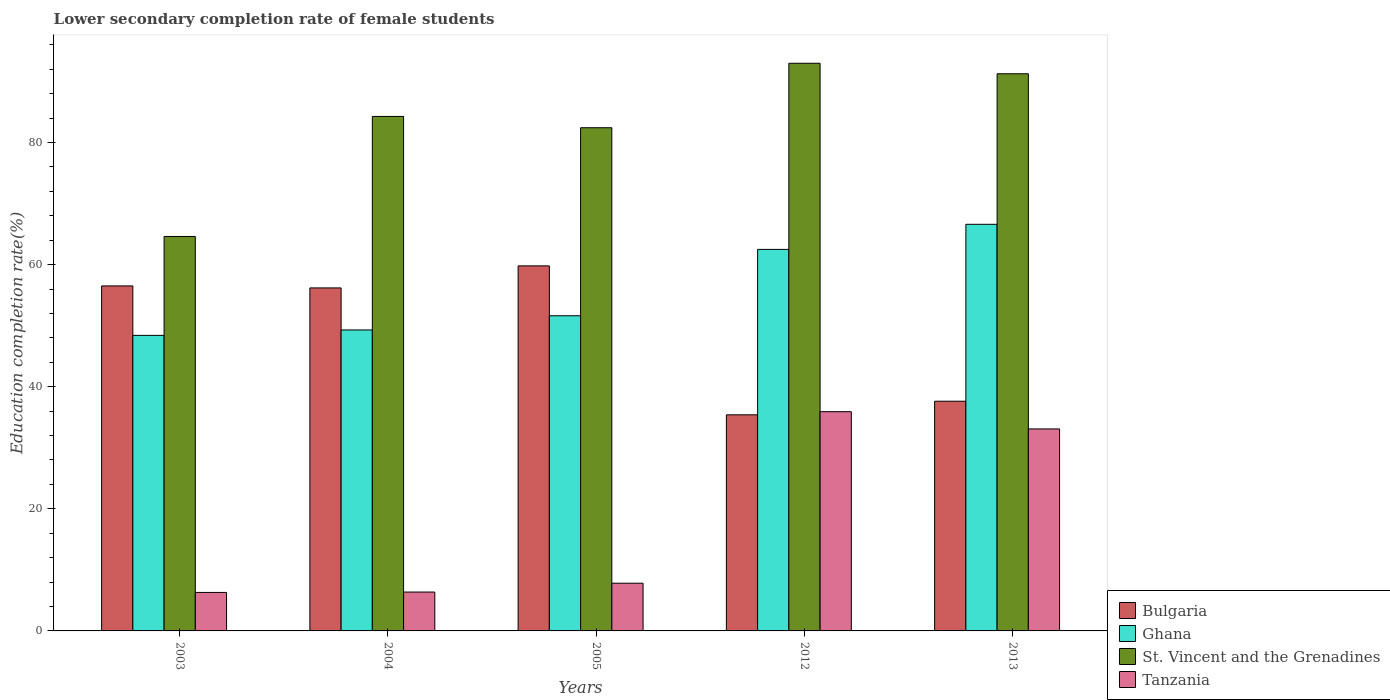How many different coloured bars are there?
Your answer should be very brief. 4. Are the number of bars on each tick of the X-axis equal?
Ensure brevity in your answer.  Yes. How many bars are there on the 4th tick from the right?
Offer a terse response. 4. What is the lower secondary completion rate of female students in Tanzania in 2005?
Ensure brevity in your answer.  7.81. Across all years, what is the maximum lower secondary completion rate of female students in Ghana?
Keep it short and to the point. 66.61. Across all years, what is the minimum lower secondary completion rate of female students in Ghana?
Your answer should be compact. 48.41. In which year was the lower secondary completion rate of female students in Ghana minimum?
Provide a succinct answer. 2003. What is the total lower secondary completion rate of female students in St. Vincent and the Grenadines in the graph?
Give a very brief answer. 415.58. What is the difference between the lower secondary completion rate of female students in Tanzania in 2004 and that in 2005?
Your answer should be compact. -1.45. What is the difference between the lower secondary completion rate of female students in Ghana in 2005 and the lower secondary completion rate of female students in Bulgaria in 2004?
Keep it short and to the point. -4.56. What is the average lower secondary completion rate of female students in Tanzania per year?
Provide a short and direct response. 17.9. In the year 2003, what is the difference between the lower secondary completion rate of female students in St. Vincent and the Grenadines and lower secondary completion rate of female students in Bulgaria?
Keep it short and to the point. 8.1. In how many years, is the lower secondary completion rate of female students in St. Vincent and the Grenadines greater than 64 %?
Offer a very short reply. 5. What is the ratio of the lower secondary completion rate of female students in Bulgaria in 2004 to that in 2012?
Provide a short and direct response. 1.59. What is the difference between the highest and the second highest lower secondary completion rate of female students in Ghana?
Your response must be concise. 4.11. What is the difference between the highest and the lowest lower secondary completion rate of female students in St. Vincent and the Grenadines?
Ensure brevity in your answer.  28.37. Is it the case that in every year, the sum of the lower secondary completion rate of female students in Ghana and lower secondary completion rate of female students in Bulgaria is greater than the sum of lower secondary completion rate of female students in St. Vincent and the Grenadines and lower secondary completion rate of female students in Tanzania?
Offer a terse response. No. What does the 3rd bar from the left in 2012 represents?
Make the answer very short. St. Vincent and the Grenadines. What does the 3rd bar from the right in 2012 represents?
Give a very brief answer. Ghana. Is it the case that in every year, the sum of the lower secondary completion rate of female students in Tanzania and lower secondary completion rate of female students in St. Vincent and the Grenadines is greater than the lower secondary completion rate of female students in Ghana?
Provide a short and direct response. Yes. How many bars are there?
Your response must be concise. 20. Are all the bars in the graph horizontal?
Ensure brevity in your answer.  No. Are the values on the major ticks of Y-axis written in scientific E-notation?
Provide a short and direct response. No. Does the graph contain any zero values?
Ensure brevity in your answer.  No. Where does the legend appear in the graph?
Make the answer very short. Bottom right. How are the legend labels stacked?
Make the answer very short. Vertical. What is the title of the graph?
Offer a terse response. Lower secondary completion rate of female students. What is the label or title of the X-axis?
Your answer should be compact. Years. What is the label or title of the Y-axis?
Make the answer very short. Education completion rate(%). What is the Education completion rate(%) in Bulgaria in 2003?
Your answer should be compact. 56.52. What is the Education completion rate(%) of Ghana in 2003?
Give a very brief answer. 48.41. What is the Education completion rate(%) of St. Vincent and the Grenadines in 2003?
Make the answer very short. 64.62. What is the Education completion rate(%) of Tanzania in 2003?
Offer a very short reply. 6.31. What is the Education completion rate(%) of Bulgaria in 2004?
Your response must be concise. 56.19. What is the Education completion rate(%) of Ghana in 2004?
Keep it short and to the point. 49.3. What is the Education completion rate(%) of St. Vincent and the Grenadines in 2004?
Provide a short and direct response. 84.28. What is the Education completion rate(%) of Tanzania in 2004?
Provide a succinct answer. 6.37. What is the Education completion rate(%) of Bulgaria in 2005?
Offer a terse response. 59.8. What is the Education completion rate(%) of Ghana in 2005?
Give a very brief answer. 51.63. What is the Education completion rate(%) of St. Vincent and the Grenadines in 2005?
Your answer should be very brief. 82.43. What is the Education completion rate(%) in Tanzania in 2005?
Make the answer very short. 7.81. What is the Education completion rate(%) of Bulgaria in 2012?
Ensure brevity in your answer.  35.4. What is the Education completion rate(%) of Ghana in 2012?
Make the answer very short. 62.5. What is the Education completion rate(%) in St. Vincent and the Grenadines in 2012?
Offer a terse response. 92.99. What is the Education completion rate(%) of Tanzania in 2012?
Keep it short and to the point. 35.92. What is the Education completion rate(%) of Bulgaria in 2013?
Offer a very short reply. 37.63. What is the Education completion rate(%) in Ghana in 2013?
Your response must be concise. 66.61. What is the Education completion rate(%) in St. Vincent and the Grenadines in 2013?
Give a very brief answer. 91.27. What is the Education completion rate(%) of Tanzania in 2013?
Ensure brevity in your answer.  33.09. Across all years, what is the maximum Education completion rate(%) in Bulgaria?
Offer a very short reply. 59.8. Across all years, what is the maximum Education completion rate(%) of Ghana?
Your answer should be compact. 66.61. Across all years, what is the maximum Education completion rate(%) of St. Vincent and the Grenadines?
Make the answer very short. 92.99. Across all years, what is the maximum Education completion rate(%) of Tanzania?
Your response must be concise. 35.92. Across all years, what is the minimum Education completion rate(%) in Bulgaria?
Ensure brevity in your answer.  35.4. Across all years, what is the minimum Education completion rate(%) of Ghana?
Your answer should be compact. 48.41. Across all years, what is the minimum Education completion rate(%) of St. Vincent and the Grenadines?
Ensure brevity in your answer.  64.62. Across all years, what is the minimum Education completion rate(%) in Tanzania?
Your answer should be compact. 6.31. What is the total Education completion rate(%) of Bulgaria in the graph?
Ensure brevity in your answer.  245.53. What is the total Education completion rate(%) in Ghana in the graph?
Your answer should be very brief. 278.45. What is the total Education completion rate(%) in St. Vincent and the Grenadines in the graph?
Your answer should be very brief. 415.58. What is the total Education completion rate(%) of Tanzania in the graph?
Give a very brief answer. 89.49. What is the difference between the Education completion rate(%) in Bulgaria in 2003 and that in 2004?
Your answer should be compact. 0.33. What is the difference between the Education completion rate(%) of Ghana in 2003 and that in 2004?
Offer a very short reply. -0.89. What is the difference between the Education completion rate(%) in St. Vincent and the Grenadines in 2003 and that in 2004?
Your answer should be compact. -19.66. What is the difference between the Education completion rate(%) in Tanzania in 2003 and that in 2004?
Ensure brevity in your answer.  -0.06. What is the difference between the Education completion rate(%) of Bulgaria in 2003 and that in 2005?
Give a very brief answer. -3.28. What is the difference between the Education completion rate(%) in Ghana in 2003 and that in 2005?
Offer a terse response. -3.21. What is the difference between the Education completion rate(%) of St. Vincent and the Grenadines in 2003 and that in 2005?
Ensure brevity in your answer.  -17.81. What is the difference between the Education completion rate(%) in Tanzania in 2003 and that in 2005?
Provide a short and direct response. -1.51. What is the difference between the Education completion rate(%) of Bulgaria in 2003 and that in 2012?
Keep it short and to the point. 21.12. What is the difference between the Education completion rate(%) in Ghana in 2003 and that in 2012?
Your answer should be compact. -14.08. What is the difference between the Education completion rate(%) of St. Vincent and the Grenadines in 2003 and that in 2012?
Provide a short and direct response. -28.37. What is the difference between the Education completion rate(%) in Tanzania in 2003 and that in 2012?
Ensure brevity in your answer.  -29.61. What is the difference between the Education completion rate(%) in Bulgaria in 2003 and that in 2013?
Offer a terse response. 18.89. What is the difference between the Education completion rate(%) of Ghana in 2003 and that in 2013?
Your response must be concise. -18.19. What is the difference between the Education completion rate(%) of St. Vincent and the Grenadines in 2003 and that in 2013?
Your answer should be compact. -26.65. What is the difference between the Education completion rate(%) in Tanzania in 2003 and that in 2013?
Offer a terse response. -26.78. What is the difference between the Education completion rate(%) of Bulgaria in 2004 and that in 2005?
Ensure brevity in your answer.  -3.61. What is the difference between the Education completion rate(%) in Ghana in 2004 and that in 2005?
Provide a short and direct response. -2.33. What is the difference between the Education completion rate(%) in St. Vincent and the Grenadines in 2004 and that in 2005?
Give a very brief answer. 1.85. What is the difference between the Education completion rate(%) of Tanzania in 2004 and that in 2005?
Your answer should be very brief. -1.45. What is the difference between the Education completion rate(%) of Bulgaria in 2004 and that in 2012?
Ensure brevity in your answer.  20.79. What is the difference between the Education completion rate(%) in Ghana in 2004 and that in 2012?
Offer a terse response. -13.2. What is the difference between the Education completion rate(%) in St. Vincent and the Grenadines in 2004 and that in 2012?
Keep it short and to the point. -8.71. What is the difference between the Education completion rate(%) of Tanzania in 2004 and that in 2012?
Offer a very short reply. -29.55. What is the difference between the Education completion rate(%) in Bulgaria in 2004 and that in 2013?
Your answer should be compact. 18.56. What is the difference between the Education completion rate(%) of Ghana in 2004 and that in 2013?
Keep it short and to the point. -17.31. What is the difference between the Education completion rate(%) of St. Vincent and the Grenadines in 2004 and that in 2013?
Make the answer very short. -6.99. What is the difference between the Education completion rate(%) of Tanzania in 2004 and that in 2013?
Offer a terse response. -26.72. What is the difference between the Education completion rate(%) in Bulgaria in 2005 and that in 2012?
Offer a terse response. 24.4. What is the difference between the Education completion rate(%) of Ghana in 2005 and that in 2012?
Offer a terse response. -10.87. What is the difference between the Education completion rate(%) in St. Vincent and the Grenadines in 2005 and that in 2012?
Keep it short and to the point. -10.56. What is the difference between the Education completion rate(%) of Tanzania in 2005 and that in 2012?
Give a very brief answer. -28.1. What is the difference between the Education completion rate(%) in Bulgaria in 2005 and that in 2013?
Provide a short and direct response. 22.17. What is the difference between the Education completion rate(%) in Ghana in 2005 and that in 2013?
Give a very brief answer. -14.98. What is the difference between the Education completion rate(%) of St. Vincent and the Grenadines in 2005 and that in 2013?
Keep it short and to the point. -8.84. What is the difference between the Education completion rate(%) in Tanzania in 2005 and that in 2013?
Your answer should be compact. -25.27. What is the difference between the Education completion rate(%) of Bulgaria in 2012 and that in 2013?
Your response must be concise. -2.23. What is the difference between the Education completion rate(%) of Ghana in 2012 and that in 2013?
Offer a terse response. -4.11. What is the difference between the Education completion rate(%) in St. Vincent and the Grenadines in 2012 and that in 2013?
Keep it short and to the point. 1.72. What is the difference between the Education completion rate(%) of Tanzania in 2012 and that in 2013?
Your answer should be very brief. 2.83. What is the difference between the Education completion rate(%) in Bulgaria in 2003 and the Education completion rate(%) in Ghana in 2004?
Provide a succinct answer. 7.22. What is the difference between the Education completion rate(%) in Bulgaria in 2003 and the Education completion rate(%) in St. Vincent and the Grenadines in 2004?
Keep it short and to the point. -27.76. What is the difference between the Education completion rate(%) in Bulgaria in 2003 and the Education completion rate(%) in Tanzania in 2004?
Offer a very short reply. 50.15. What is the difference between the Education completion rate(%) of Ghana in 2003 and the Education completion rate(%) of St. Vincent and the Grenadines in 2004?
Provide a succinct answer. -35.86. What is the difference between the Education completion rate(%) of Ghana in 2003 and the Education completion rate(%) of Tanzania in 2004?
Give a very brief answer. 42.05. What is the difference between the Education completion rate(%) in St. Vincent and the Grenadines in 2003 and the Education completion rate(%) in Tanzania in 2004?
Give a very brief answer. 58.25. What is the difference between the Education completion rate(%) of Bulgaria in 2003 and the Education completion rate(%) of Ghana in 2005?
Give a very brief answer. 4.89. What is the difference between the Education completion rate(%) of Bulgaria in 2003 and the Education completion rate(%) of St. Vincent and the Grenadines in 2005?
Your answer should be very brief. -25.91. What is the difference between the Education completion rate(%) of Bulgaria in 2003 and the Education completion rate(%) of Tanzania in 2005?
Give a very brief answer. 48.7. What is the difference between the Education completion rate(%) of Ghana in 2003 and the Education completion rate(%) of St. Vincent and the Grenadines in 2005?
Offer a terse response. -34.01. What is the difference between the Education completion rate(%) in Ghana in 2003 and the Education completion rate(%) in Tanzania in 2005?
Your answer should be compact. 40.6. What is the difference between the Education completion rate(%) in St. Vincent and the Grenadines in 2003 and the Education completion rate(%) in Tanzania in 2005?
Your answer should be compact. 56.8. What is the difference between the Education completion rate(%) in Bulgaria in 2003 and the Education completion rate(%) in Ghana in 2012?
Your response must be concise. -5.98. What is the difference between the Education completion rate(%) of Bulgaria in 2003 and the Education completion rate(%) of St. Vincent and the Grenadines in 2012?
Your response must be concise. -36.47. What is the difference between the Education completion rate(%) of Bulgaria in 2003 and the Education completion rate(%) of Tanzania in 2012?
Keep it short and to the point. 20.6. What is the difference between the Education completion rate(%) in Ghana in 2003 and the Education completion rate(%) in St. Vincent and the Grenadines in 2012?
Your answer should be very brief. -44.57. What is the difference between the Education completion rate(%) in Ghana in 2003 and the Education completion rate(%) in Tanzania in 2012?
Make the answer very short. 12.5. What is the difference between the Education completion rate(%) in St. Vincent and the Grenadines in 2003 and the Education completion rate(%) in Tanzania in 2012?
Your answer should be very brief. 28.7. What is the difference between the Education completion rate(%) of Bulgaria in 2003 and the Education completion rate(%) of Ghana in 2013?
Ensure brevity in your answer.  -10.09. What is the difference between the Education completion rate(%) of Bulgaria in 2003 and the Education completion rate(%) of St. Vincent and the Grenadines in 2013?
Make the answer very short. -34.75. What is the difference between the Education completion rate(%) of Bulgaria in 2003 and the Education completion rate(%) of Tanzania in 2013?
Your response must be concise. 23.43. What is the difference between the Education completion rate(%) in Ghana in 2003 and the Education completion rate(%) in St. Vincent and the Grenadines in 2013?
Your answer should be very brief. -42.86. What is the difference between the Education completion rate(%) of Ghana in 2003 and the Education completion rate(%) of Tanzania in 2013?
Your response must be concise. 15.32. What is the difference between the Education completion rate(%) in St. Vincent and the Grenadines in 2003 and the Education completion rate(%) in Tanzania in 2013?
Give a very brief answer. 31.53. What is the difference between the Education completion rate(%) of Bulgaria in 2004 and the Education completion rate(%) of Ghana in 2005?
Your response must be concise. 4.56. What is the difference between the Education completion rate(%) in Bulgaria in 2004 and the Education completion rate(%) in St. Vincent and the Grenadines in 2005?
Your answer should be very brief. -26.24. What is the difference between the Education completion rate(%) in Bulgaria in 2004 and the Education completion rate(%) in Tanzania in 2005?
Provide a succinct answer. 48.37. What is the difference between the Education completion rate(%) in Ghana in 2004 and the Education completion rate(%) in St. Vincent and the Grenadines in 2005?
Provide a short and direct response. -33.13. What is the difference between the Education completion rate(%) of Ghana in 2004 and the Education completion rate(%) of Tanzania in 2005?
Offer a very short reply. 41.48. What is the difference between the Education completion rate(%) in St. Vincent and the Grenadines in 2004 and the Education completion rate(%) in Tanzania in 2005?
Offer a terse response. 76.46. What is the difference between the Education completion rate(%) in Bulgaria in 2004 and the Education completion rate(%) in Ghana in 2012?
Offer a terse response. -6.31. What is the difference between the Education completion rate(%) in Bulgaria in 2004 and the Education completion rate(%) in St. Vincent and the Grenadines in 2012?
Your answer should be compact. -36.8. What is the difference between the Education completion rate(%) of Bulgaria in 2004 and the Education completion rate(%) of Tanzania in 2012?
Provide a short and direct response. 20.27. What is the difference between the Education completion rate(%) of Ghana in 2004 and the Education completion rate(%) of St. Vincent and the Grenadines in 2012?
Offer a very short reply. -43.69. What is the difference between the Education completion rate(%) in Ghana in 2004 and the Education completion rate(%) in Tanzania in 2012?
Give a very brief answer. 13.38. What is the difference between the Education completion rate(%) in St. Vincent and the Grenadines in 2004 and the Education completion rate(%) in Tanzania in 2012?
Offer a terse response. 48.36. What is the difference between the Education completion rate(%) of Bulgaria in 2004 and the Education completion rate(%) of Ghana in 2013?
Provide a succinct answer. -10.42. What is the difference between the Education completion rate(%) of Bulgaria in 2004 and the Education completion rate(%) of St. Vincent and the Grenadines in 2013?
Your response must be concise. -35.08. What is the difference between the Education completion rate(%) of Bulgaria in 2004 and the Education completion rate(%) of Tanzania in 2013?
Offer a terse response. 23.1. What is the difference between the Education completion rate(%) in Ghana in 2004 and the Education completion rate(%) in St. Vincent and the Grenadines in 2013?
Give a very brief answer. -41.97. What is the difference between the Education completion rate(%) of Ghana in 2004 and the Education completion rate(%) of Tanzania in 2013?
Provide a succinct answer. 16.21. What is the difference between the Education completion rate(%) in St. Vincent and the Grenadines in 2004 and the Education completion rate(%) in Tanzania in 2013?
Provide a short and direct response. 51.19. What is the difference between the Education completion rate(%) of Bulgaria in 2005 and the Education completion rate(%) of Ghana in 2012?
Keep it short and to the point. -2.7. What is the difference between the Education completion rate(%) of Bulgaria in 2005 and the Education completion rate(%) of St. Vincent and the Grenadines in 2012?
Offer a terse response. -33.19. What is the difference between the Education completion rate(%) of Bulgaria in 2005 and the Education completion rate(%) of Tanzania in 2012?
Offer a very short reply. 23.88. What is the difference between the Education completion rate(%) in Ghana in 2005 and the Education completion rate(%) in St. Vincent and the Grenadines in 2012?
Give a very brief answer. -41.36. What is the difference between the Education completion rate(%) in Ghana in 2005 and the Education completion rate(%) in Tanzania in 2012?
Ensure brevity in your answer.  15.71. What is the difference between the Education completion rate(%) in St. Vincent and the Grenadines in 2005 and the Education completion rate(%) in Tanzania in 2012?
Your answer should be very brief. 46.51. What is the difference between the Education completion rate(%) of Bulgaria in 2005 and the Education completion rate(%) of Ghana in 2013?
Your answer should be compact. -6.81. What is the difference between the Education completion rate(%) in Bulgaria in 2005 and the Education completion rate(%) in St. Vincent and the Grenadines in 2013?
Keep it short and to the point. -31.47. What is the difference between the Education completion rate(%) in Bulgaria in 2005 and the Education completion rate(%) in Tanzania in 2013?
Your response must be concise. 26.71. What is the difference between the Education completion rate(%) of Ghana in 2005 and the Education completion rate(%) of St. Vincent and the Grenadines in 2013?
Your answer should be very brief. -39.64. What is the difference between the Education completion rate(%) of Ghana in 2005 and the Education completion rate(%) of Tanzania in 2013?
Offer a terse response. 18.54. What is the difference between the Education completion rate(%) of St. Vincent and the Grenadines in 2005 and the Education completion rate(%) of Tanzania in 2013?
Ensure brevity in your answer.  49.34. What is the difference between the Education completion rate(%) in Bulgaria in 2012 and the Education completion rate(%) in Ghana in 2013?
Offer a very short reply. -31.21. What is the difference between the Education completion rate(%) in Bulgaria in 2012 and the Education completion rate(%) in St. Vincent and the Grenadines in 2013?
Keep it short and to the point. -55.87. What is the difference between the Education completion rate(%) of Bulgaria in 2012 and the Education completion rate(%) of Tanzania in 2013?
Your answer should be very brief. 2.31. What is the difference between the Education completion rate(%) in Ghana in 2012 and the Education completion rate(%) in St. Vincent and the Grenadines in 2013?
Keep it short and to the point. -28.77. What is the difference between the Education completion rate(%) of Ghana in 2012 and the Education completion rate(%) of Tanzania in 2013?
Your answer should be very brief. 29.41. What is the difference between the Education completion rate(%) of St. Vincent and the Grenadines in 2012 and the Education completion rate(%) of Tanzania in 2013?
Give a very brief answer. 59.9. What is the average Education completion rate(%) of Bulgaria per year?
Make the answer very short. 49.11. What is the average Education completion rate(%) of Ghana per year?
Offer a terse response. 55.69. What is the average Education completion rate(%) of St. Vincent and the Grenadines per year?
Offer a very short reply. 83.12. What is the average Education completion rate(%) in Tanzania per year?
Your answer should be very brief. 17.9. In the year 2003, what is the difference between the Education completion rate(%) in Bulgaria and Education completion rate(%) in Ghana?
Ensure brevity in your answer.  8.1. In the year 2003, what is the difference between the Education completion rate(%) of Bulgaria and Education completion rate(%) of St. Vincent and the Grenadines?
Offer a terse response. -8.1. In the year 2003, what is the difference between the Education completion rate(%) in Bulgaria and Education completion rate(%) in Tanzania?
Provide a succinct answer. 50.21. In the year 2003, what is the difference between the Education completion rate(%) in Ghana and Education completion rate(%) in St. Vincent and the Grenadines?
Your answer should be very brief. -16.2. In the year 2003, what is the difference between the Education completion rate(%) of Ghana and Education completion rate(%) of Tanzania?
Your response must be concise. 42.11. In the year 2003, what is the difference between the Education completion rate(%) of St. Vincent and the Grenadines and Education completion rate(%) of Tanzania?
Offer a terse response. 58.31. In the year 2004, what is the difference between the Education completion rate(%) of Bulgaria and Education completion rate(%) of Ghana?
Your answer should be very brief. 6.89. In the year 2004, what is the difference between the Education completion rate(%) in Bulgaria and Education completion rate(%) in St. Vincent and the Grenadines?
Provide a succinct answer. -28.09. In the year 2004, what is the difference between the Education completion rate(%) of Bulgaria and Education completion rate(%) of Tanzania?
Your response must be concise. 49.82. In the year 2004, what is the difference between the Education completion rate(%) in Ghana and Education completion rate(%) in St. Vincent and the Grenadines?
Your answer should be compact. -34.98. In the year 2004, what is the difference between the Education completion rate(%) of Ghana and Education completion rate(%) of Tanzania?
Provide a succinct answer. 42.93. In the year 2004, what is the difference between the Education completion rate(%) in St. Vincent and the Grenadines and Education completion rate(%) in Tanzania?
Ensure brevity in your answer.  77.91. In the year 2005, what is the difference between the Education completion rate(%) in Bulgaria and Education completion rate(%) in Ghana?
Your answer should be compact. 8.17. In the year 2005, what is the difference between the Education completion rate(%) in Bulgaria and Education completion rate(%) in St. Vincent and the Grenadines?
Make the answer very short. -22.63. In the year 2005, what is the difference between the Education completion rate(%) of Bulgaria and Education completion rate(%) of Tanzania?
Ensure brevity in your answer.  51.98. In the year 2005, what is the difference between the Education completion rate(%) of Ghana and Education completion rate(%) of St. Vincent and the Grenadines?
Your answer should be compact. -30.8. In the year 2005, what is the difference between the Education completion rate(%) in Ghana and Education completion rate(%) in Tanzania?
Ensure brevity in your answer.  43.81. In the year 2005, what is the difference between the Education completion rate(%) in St. Vincent and the Grenadines and Education completion rate(%) in Tanzania?
Provide a succinct answer. 74.61. In the year 2012, what is the difference between the Education completion rate(%) in Bulgaria and Education completion rate(%) in Ghana?
Offer a terse response. -27.1. In the year 2012, what is the difference between the Education completion rate(%) in Bulgaria and Education completion rate(%) in St. Vincent and the Grenadines?
Make the answer very short. -57.59. In the year 2012, what is the difference between the Education completion rate(%) in Bulgaria and Education completion rate(%) in Tanzania?
Provide a short and direct response. -0.51. In the year 2012, what is the difference between the Education completion rate(%) of Ghana and Education completion rate(%) of St. Vincent and the Grenadines?
Your answer should be compact. -30.49. In the year 2012, what is the difference between the Education completion rate(%) of Ghana and Education completion rate(%) of Tanzania?
Give a very brief answer. 26.58. In the year 2012, what is the difference between the Education completion rate(%) in St. Vincent and the Grenadines and Education completion rate(%) in Tanzania?
Give a very brief answer. 57.07. In the year 2013, what is the difference between the Education completion rate(%) of Bulgaria and Education completion rate(%) of Ghana?
Keep it short and to the point. -28.98. In the year 2013, what is the difference between the Education completion rate(%) in Bulgaria and Education completion rate(%) in St. Vincent and the Grenadines?
Provide a succinct answer. -53.64. In the year 2013, what is the difference between the Education completion rate(%) of Bulgaria and Education completion rate(%) of Tanzania?
Ensure brevity in your answer.  4.54. In the year 2013, what is the difference between the Education completion rate(%) of Ghana and Education completion rate(%) of St. Vincent and the Grenadines?
Give a very brief answer. -24.66. In the year 2013, what is the difference between the Education completion rate(%) in Ghana and Education completion rate(%) in Tanzania?
Your answer should be very brief. 33.52. In the year 2013, what is the difference between the Education completion rate(%) in St. Vincent and the Grenadines and Education completion rate(%) in Tanzania?
Offer a very short reply. 58.18. What is the ratio of the Education completion rate(%) in St. Vincent and the Grenadines in 2003 to that in 2004?
Provide a short and direct response. 0.77. What is the ratio of the Education completion rate(%) of Bulgaria in 2003 to that in 2005?
Give a very brief answer. 0.95. What is the ratio of the Education completion rate(%) of Ghana in 2003 to that in 2005?
Your answer should be compact. 0.94. What is the ratio of the Education completion rate(%) in St. Vincent and the Grenadines in 2003 to that in 2005?
Provide a succinct answer. 0.78. What is the ratio of the Education completion rate(%) of Tanzania in 2003 to that in 2005?
Offer a very short reply. 0.81. What is the ratio of the Education completion rate(%) in Bulgaria in 2003 to that in 2012?
Offer a very short reply. 1.6. What is the ratio of the Education completion rate(%) of Ghana in 2003 to that in 2012?
Give a very brief answer. 0.77. What is the ratio of the Education completion rate(%) of St. Vincent and the Grenadines in 2003 to that in 2012?
Make the answer very short. 0.69. What is the ratio of the Education completion rate(%) in Tanzania in 2003 to that in 2012?
Offer a terse response. 0.18. What is the ratio of the Education completion rate(%) of Bulgaria in 2003 to that in 2013?
Keep it short and to the point. 1.5. What is the ratio of the Education completion rate(%) of Ghana in 2003 to that in 2013?
Offer a very short reply. 0.73. What is the ratio of the Education completion rate(%) of St. Vincent and the Grenadines in 2003 to that in 2013?
Offer a terse response. 0.71. What is the ratio of the Education completion rate(%) of Tanzania in 2003 to that in 2013?
Offer a terse response. 0.19. What is the ratio of the Education completion rate(%) of Bulgaria in 2004 to that in 2005?
Give a very brief answer. 0.94. What is the ratio of the Education completion rate(%) of Ghana in 2004 to that in 2005?
Keep it short and to the point. 0.95. What is the ratio of the Education completion rate(%) of St. Vincent and the Grenadines in 2004 to that in 2005?
Offer a very short reply. 1.02. What is the ratio of the Education completion rate(%) in Tanzania in 2004 to that in 2005?
Your answer should be compact. 0.81. What is the ratio of the Education completion rate(%) of Bulgaria in 2004 to that in 2012?
Your response must be concise. 1.59. What is the ratio of the Education completion rate(%) of Ghana in 2004 to that in 2012?
Your answer should be very brief. 0.79. What is the ratio of the Education completion rate(%) in St. Vincent and the Grenadines in 2004 to that in 2012?
Your response must be concise. 0.91. What is the ratio of the Education completion rate(%) in Tanzania in 2004 to that in 2012?
Make the answer very short. 0.18. What is the ratio of the Education completion rate(%) in Bulgaria in 2004 to that in 2013?
Provide a succinct answer. 1.49. What is the ratio of the Education completion rate(%) of Ghana in 2004 to that in 2013?
Ensure brevity in your answer.  0.74. What is the ratio of the Education completion rate(%) of St. Vincent and the Grenadines in 2004 to that in 2013?
Offer a terse response. 0.92. What is the ratio of the Education completion rate(%) of Tanzania in 2004 to that in 2013?
Keep it short and to the point. 0.19. What is the ratio of the Education completion rate(%) in Bulgaria in 2005 to that in 2012?
Give a very brief answer. 1.69. What is the ratio of the Education completion rate(%) of Ghana in 2005 to that in 2012?
Offer a very short reply. 0.83. What is the ratio of the Education completion rate(%) in St. Vincent and the Grenadines in 2005 to that in 2012?
Provide a short and direct response. 0.89. What is the ratio of the Education completion rate(%) of Tanzania in 2005 to that in 2012?
Provide a short and direct response. 0.22. What is the ratio of the Education completion rate(%) in Bulgaria in 2005 to that in 2013?
Provide a short and direct response. 1.59. What is the ratio of the Education completion rate(%) in Ghana in 2005 to that in 2013?
Provide a short and direct response. 0.78. What is the ratio of the Education completion rate(%) of St. Vincent and the Grenadines in 2005 to that in 2013?
Ensure brevity in your answer.  0.9. What is the ratio of the Education completion rate(%) of Tanzania in 2005 to that in 2013?
Your answer should be very brief. 0.24. What is the ratio of the Education completion rate(%) in Bulgaria in 2012 to that in 2013?
Your response must be concise. 0.94. What is the ratio of the Education completion rate(%) of Ghana in 2012 to that in 2013?
Provide a short and direct response. 0.94. What is the ratio of the Education completion rate(%) in St. Vincent and the Grenadines in 2012 to that in 2013?
Ensure brevity in your answer.  1.02. What is the ratio of the Education completion rate(%) in Tanzania in 2012 to that in 2013?
Provide a short and direct response. 1.09. What is the difference between the highest and the second highest Education completion rate(%) of Bulgaria?
Provide a short and direct response. 3.28. What is the difference between the highest and the second highest Education completion rate(%) of Ghana?
Your answer should be compact. 4.11. What is the difference between the highest and the second highest Education completion rate(%) of St. Vincent and the Grenadines?
Your answer should be compact. 1.72. What is the difference between the highest and the second highest Education completion rate(%) in Tanzania?
Your answer should be very brief. 2.83. What is the difference between the highest and the lowest Education completion rate(%) in Bulgaria?
Ensure brevity in your answer.  24.4. What is the difference between the highest and the lowest Education completion rate(%) of Ghana?
Ensure brevity in your answer.  18.19. What is the difference between the highest and the lowest Education completion rate(%) of St. Vincent and the Grenadines?
Keep it short and to the point. 28.37. What is the difference between the highest and the lowest Education completion rate(%) of Tanzania?
Make the answer very short. 29.61. 